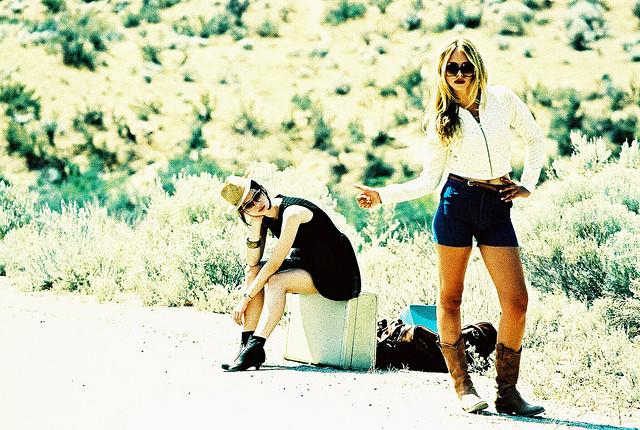What are the women doing on the road? Please explain your reasoning. posing. The women are posing for a picture and pretending as though they are hitchhikers. the image is a photograph for advertising purposes. 